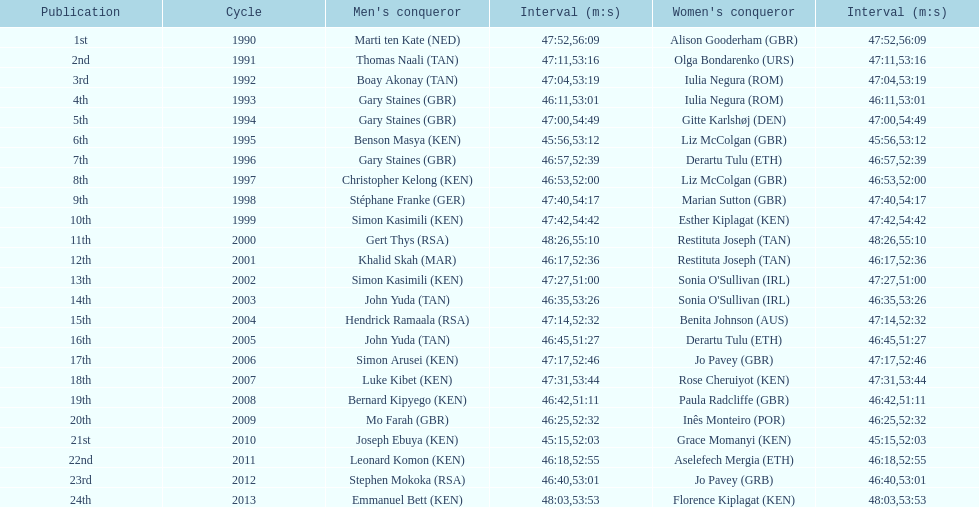Who is the male winner listed before gert thys? Simon Kasimili. 